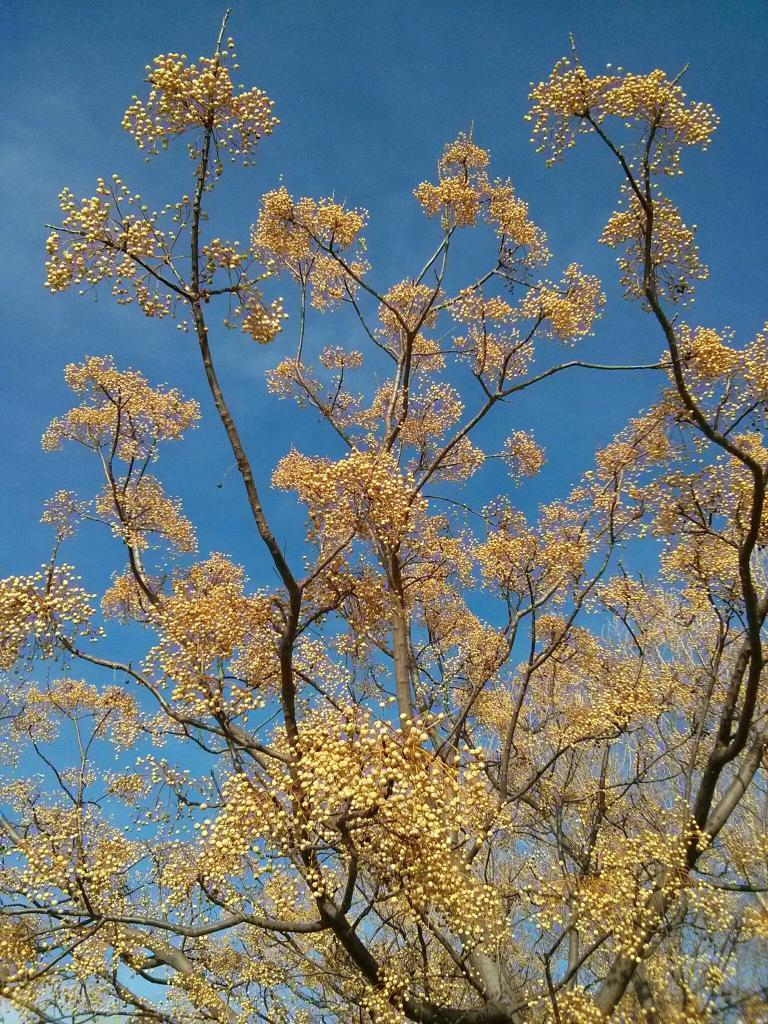What type of plant can be seen in the image? There is a tree in the image. What part of the natural environment is visible in the image? The sky is visible in the image. What type of operation is being performed on the tree in the image? There is no operation being performed on the tree in the image; it is simply a tree standing in its natural environment. 